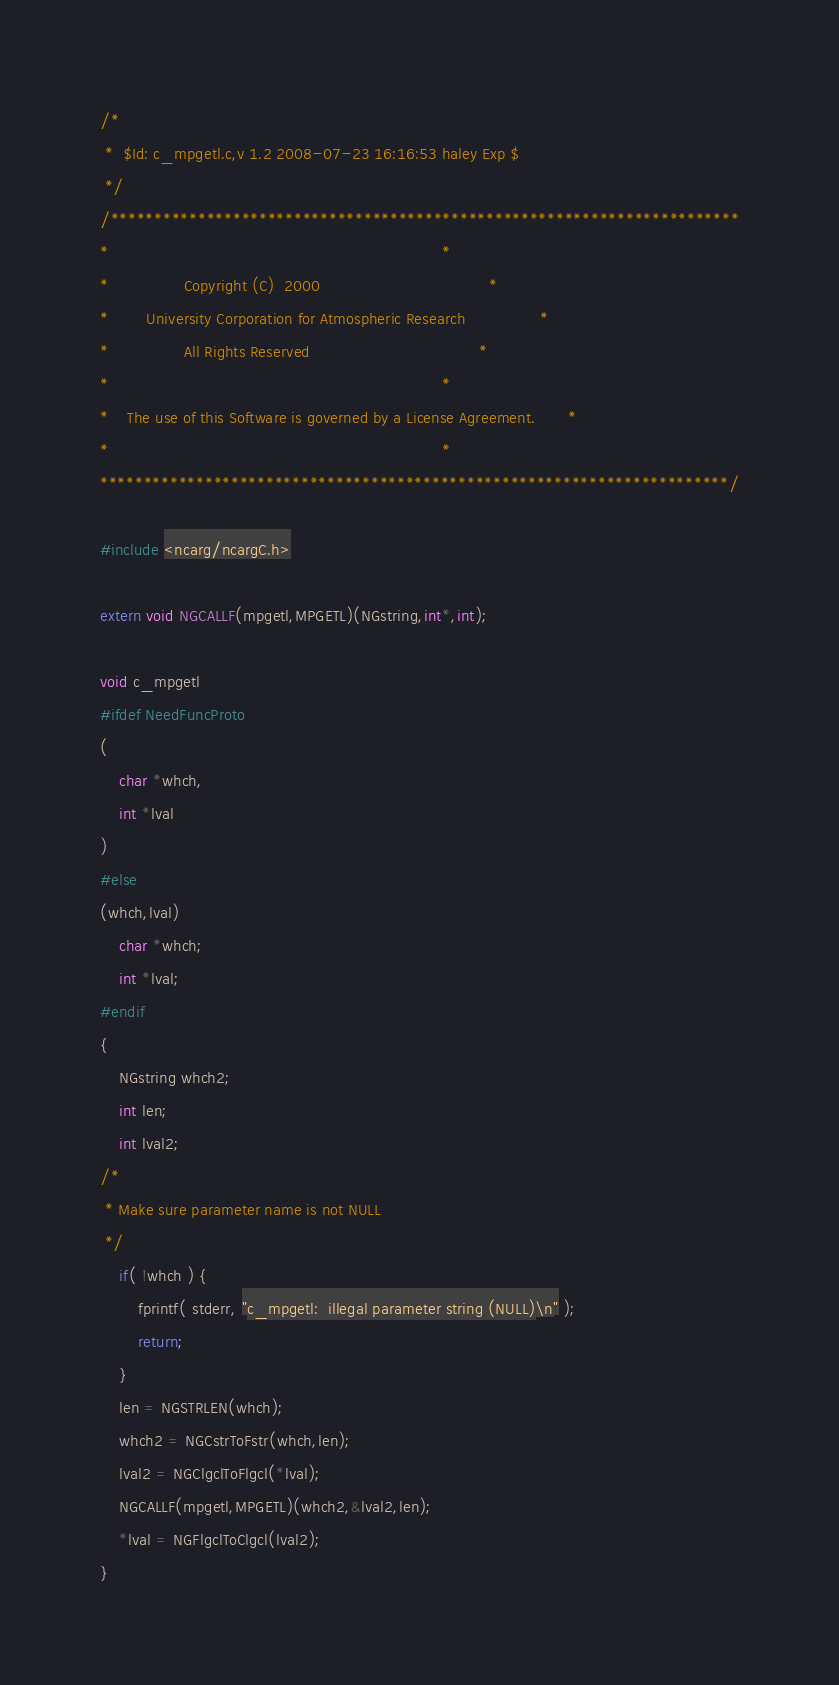Convert code to text. <code><loc_0><loc_0><loc_500><loc_500><_C_>/*
 *	$Id: c_mpgetl.c,v 1.2 2008-07-23 16:16:53 haley Exp $
 */
/************************************************************************
*                                                                       *
*                Copyright (C)  2000                                    *
*        University Corporation for Atmospheric Research                *
*                All Rights Reserved                                    *
*                                                                       *
*    The use of this Software is governed by a License Agreement.       *
*                                                                       *
************************************************************************/

#include <ncarg/ncargC.h>

extern void NGCALLF(mpgetl,MPGETL)(NGstring,int*,int);

void c_mpgetl
#ifdef NeedFuncProto
(
    char *whch,
    int *lval
)
#else
(whch,lval)
    char *whch;
    int *lval;
#endif
{
    NGstring whch2;
    int len;
    int lval2;
/*
 * Make sure parameter name is not NULL
 */
    if( !whch ) { 
        fprintf( stderr, "c_mpgetl:  illegal parameter string (NULL)\n" );
        return;
    }
    len = NGSTRLEN(whch);
    whch2 = NGCstrToFstr(whch,len);
    lval2 = NGClgclToFlgcl(*lval);
    NGCALLF(mpgetl,MPGETL)(whch2,&lval2,len);
    *lval = NGFlgclToClgcl(lval2);
}
</code> 